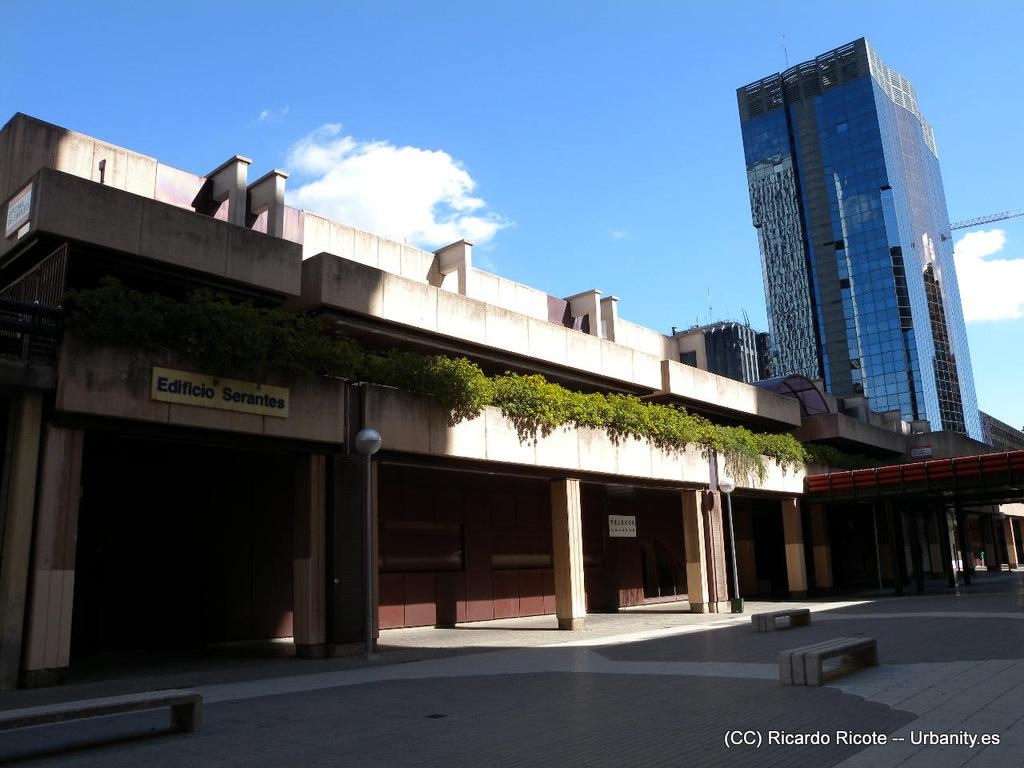What type of structures are visible in the image? There are houses and buildings in the image. What is located at the bottom of the image? There is a floor at the bottom of the image. What can be seen in the center of the image? There are plants and a board in the center of the image. What is visible at the top of the image? The sky is visible at the top of the image. How many grapes are hanging from the plants in the image? There are no grapes visible in the image; the plants are not specified as grape plants. What type of oil can be seen dripping from the board in the image? There is no oil present in the image; the board is not associated with any oil. 